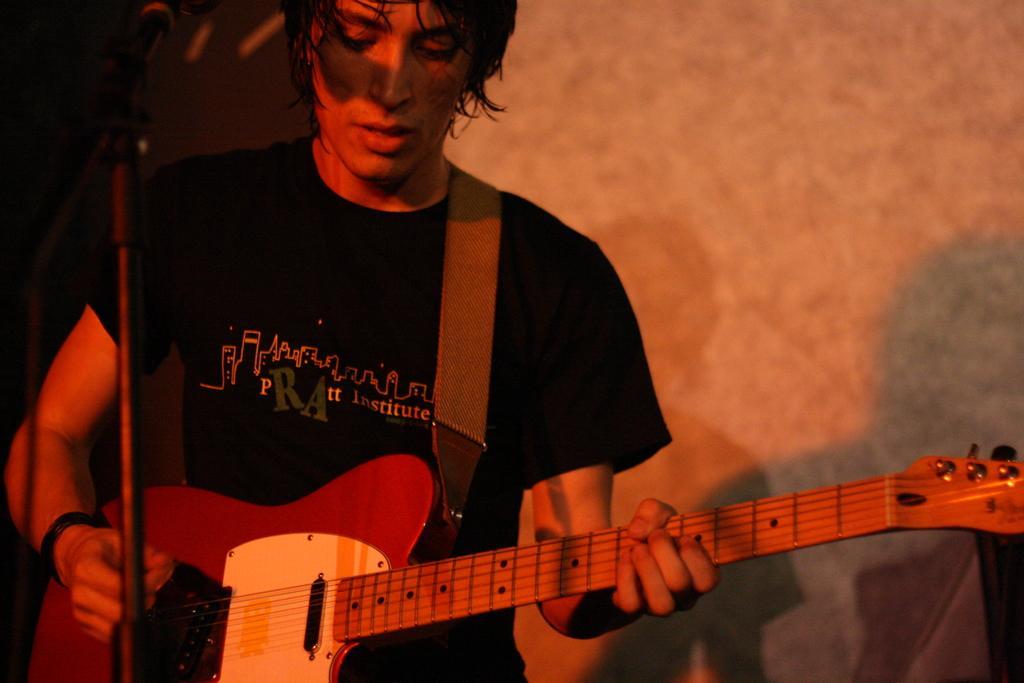Please provide a concise description of this image. in this picture we can see a man wearing a black color t shirt, standing in front of a mike singing and playing guitar. 